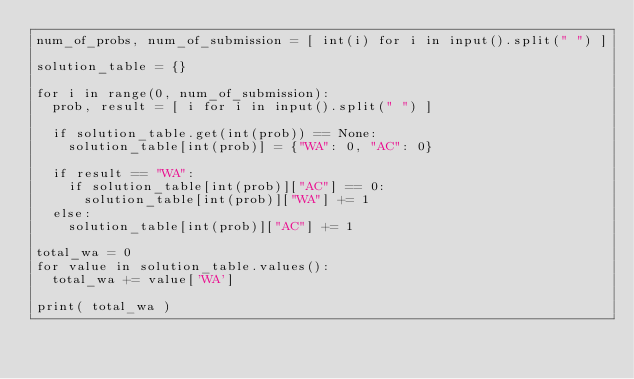Convert code to text. <code><loc_0><loc_0><loc_500><loc_500><_Python_>num_of_probs, num_of_submission = [ int(i) for i in input().split(" ") ]

solution_table = {}

for i in range(0, num_of_submission):
  prob, result = [ i for i in input().split(" ") ]

  if solution_table.get(int(prob)) == None:
    solution_table[int(prob)] = {"WA": 0, "AC": 0}

  if result == "WA":
    if solution_table[int(prob)]["AC"] == 0:
      solution_table[int(prob)]["WA"] += 1
  else:
    solution_table[int(prob)]["AC"] += 1

total_wa = 0
for value in solution_table.values():
  total_wa += value['WA']

print( total_wa )</code> 